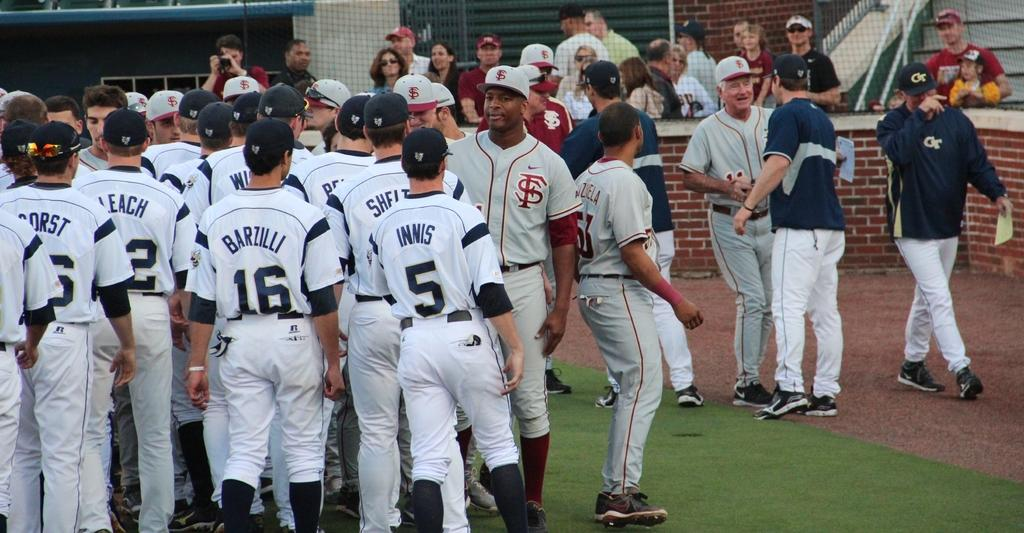<image>
Present a compact description of the photo's key features. Baseball player wearing number 5 going into the huddle. 